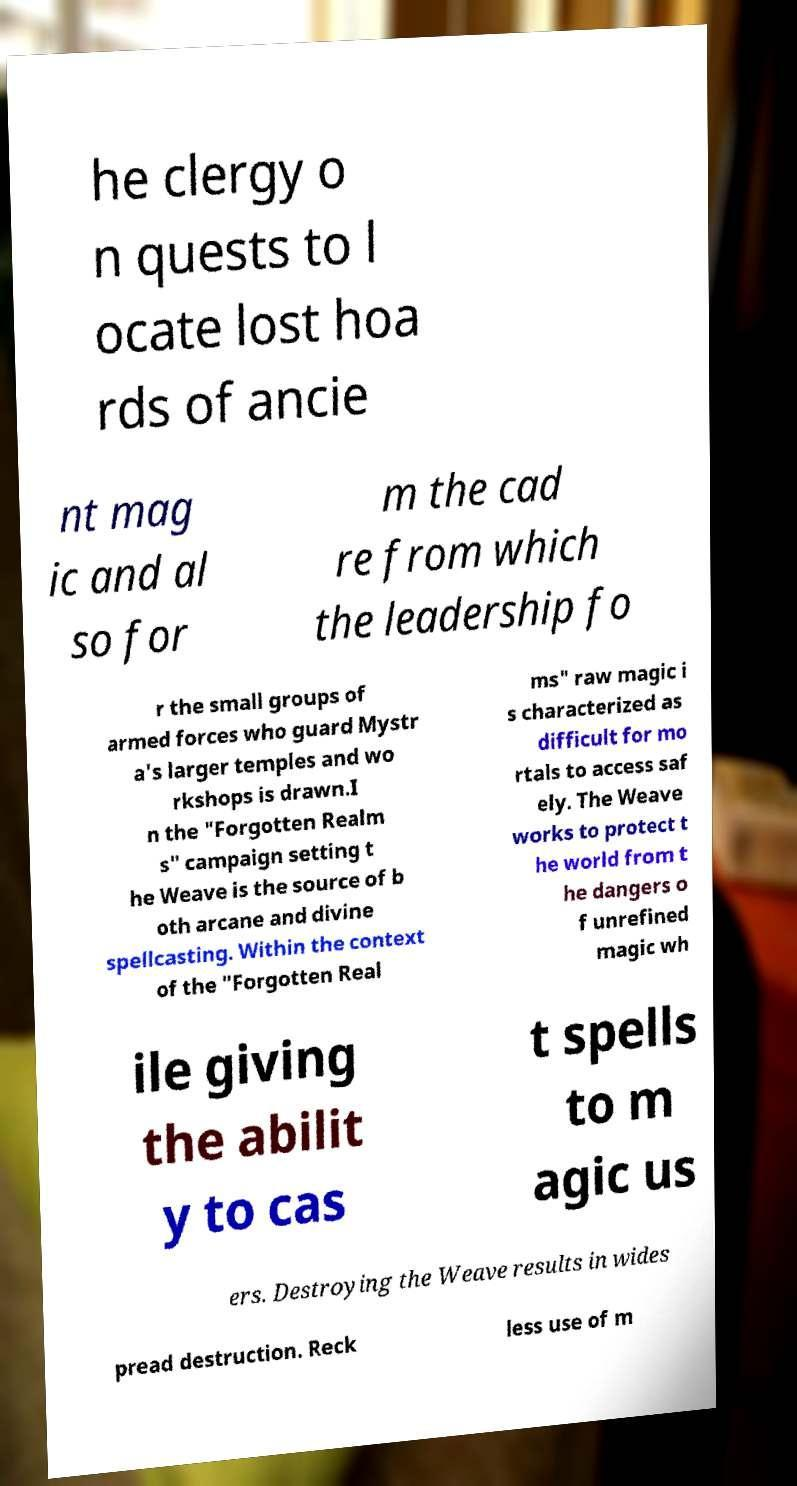Can you read and provide the text displayed in the image?This photo seems to have some interesting text. Can you extract and type it out for me? he clergy o n quests to l ocate lost hoa rds of ancie nt mag ic and al so for m the cad re from which the leadership fo r the small groups of armed forces who guard Mystr a's larger temples and wo rkshops is drawn.I n the "Forgotten Realm s" campaign setting t he Weave is the source of b oth arcane and divine spellcasting. Within the context of the "Forgotten Real ms" raw magic i s characterized as difficult for mo rtals to access saf ely. The Weave works to protect t he world from t he dangers o f unrefined magic wh ile giving the abilit y to cas t spells to m agic us ers. Destroying the Weave results in wides pread destruction. Reck less use of m 